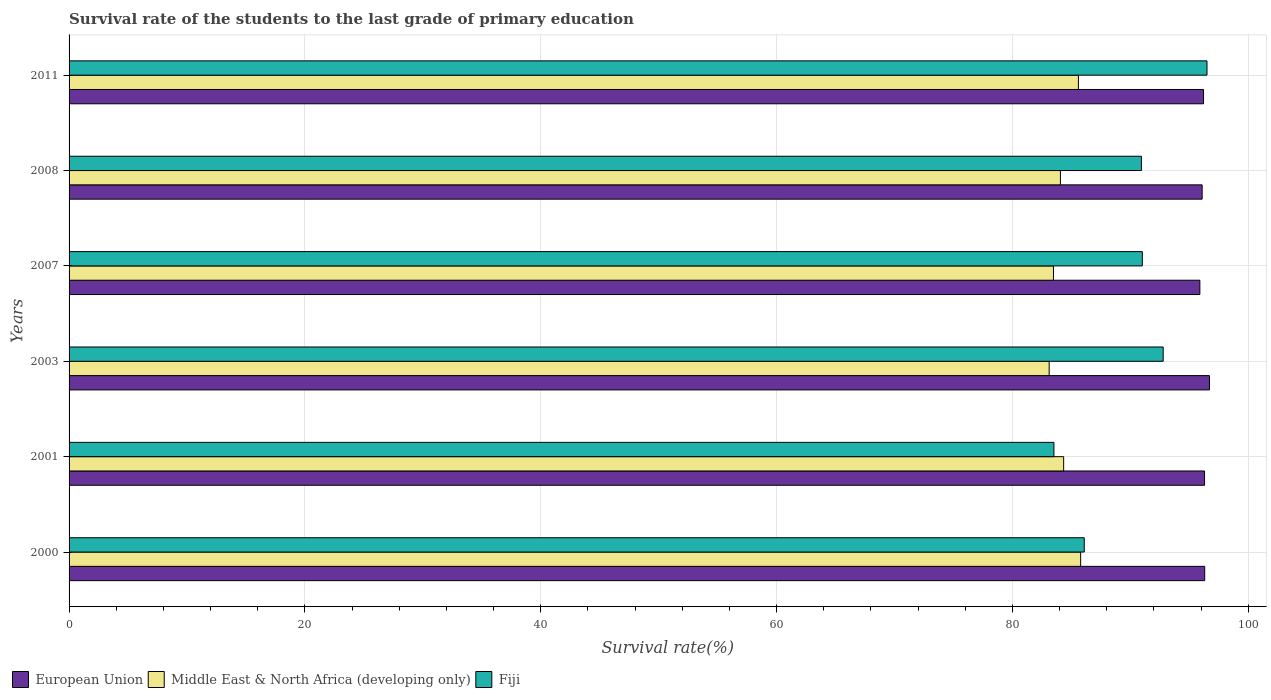How many different coloured bars are there?
Ensure brevity in your answer.  3. How many groups of bars are there?
Your response must be concise. 6. Are the number of bars on each tick of the Y-axis equal?
Provide a succinct answer. Yes. What is the survival rate of the students in Middle East & North Africa (developing only) in 2008?
Your response must be concise. 84.08. Across all years, what is the maximum survival rate of the students in Fiji?
Give a very brief answer. 96.51. Across all years, what is the minimum survival rate of the students in European Union?
Give a very brief answer. 95.9. In which year was the survival rate of the students in Middle East & North Africa (developing only) minimum?
Your response must be concise. 2003. What is the total survival rate of the students in Fiji in the graph?
Your answer should be compact. 540.89. What is the difference between the survival rate of the students in Middle East & North Africa (developing only) in 2008 and that in 2011?
Give a very brief answer. -1.53. What is the difference between the survival rate of the students in Middle East & North Africa (developing only) in 2011 and the survival rate of the students in European Union in 2008?
Make the answer very short. -10.49. What is the average survival rate of the students in European Union per year?
Offer a terse response. 96.26. In the year 2003, what is the difference between the survival rate of the students in European Union and survival rate of the students in Middle East & North Africa (developing only)?
Ensure brevity in your answer.  13.6. What is the ratio of the survival rate of the students in European Union in 2003 to that in 2011?
Provide a short and direct response. 1.01. Is the survival rate of the students in Middle East & North Africa (developing only) in 2000 less than that in 2007?
Provide a short and direct response. No. What is the difference between the highest and the second highest survival rate of the students in Middle East & North Africa (developing only)?
Provide a short and direct response. 0.19. What is the difference between the highest and the lowest survival rate of the students in Middle East & North Africa (developing only)?
Your answer should be compact. 2.67. Is the sum of the survival rate of the students in Middle East & North Africa (developing only) in 2000 and 2003 greater than the maximum survival rate of the students in European Union across all years?
Keep it short and to the point. Yes. What does the 2nd bar from the top in 2001 represents?
Your answer should be very brief. Middle East & North Africa (developing only). What does the 1st bar from the bottom in 2000 represents?
Offer a terse response. European Union. How many bars are there?
Ensure brevity in your answer.  18. Are all the bars in the graph horizontal?
Provide a succinct answer. Yes. What is the difference between two consecutive major ticks on the X-axis?
Your response must be concise. 20. Does the graph contain grids?
Your answer should be compact. Yes. Where does the legend appear in the graph?
Offer a very short reply. Bottom left. How many legend labels are there?
Make the answer very short. 3. What is the title of the graph?
Your answer should be compact. Survival rate of the students to the last grade of primary education. What is the label or title of the X-axis?
Make the answer very short. Survival rate(%). What is the label or title of the Y-axis?
Offer a terse response. Years. What is the Survival rate(%) in European Union in 2000?
Provide a short and direct response. 96.31. What is the Survival rate(%) in Middle East & North Africa (developing only) in 2000?
Provide a short and direct response. 85.79. What is the Survival rate(%) in Fiji in 2000?
Your answer should be very brief. 86.1. What is the Survival rate(%) of European Union in 2001?
Your answer should be very brief. 96.3. What is the Survival rate(%) of Middle East & North Africa (developing only) in 2001?
Ensure brevity in your answer.  84.35. What is the Survival rate(%) in Fiji in 2001?
Your response must be concise. 83.53. What is the Survival rate(%) of European Union in 2003?
Ensure brevity in your answer.  96.72. What is the Survival rate(%) of Middle East & North Africa (developing only) in 2003?
Keep it short and to the point. 83.12. What is the Survival rate(%) in Fiji in 2003?
Make the answer very short. 92.79. What is the Survival rate(%) in European Union in 2007?
Make the answer very short. 95.9. What is the Survival rate(%) in Middle East & North Africa (developing only) in 2007?
Your answer should be compact. 83.49. What is the Survival rate(%) in Fiji in 2007?
Provide a succinct answer. 91.02. What is the Survival rate(%) of European Union in 2008?
Your response must be concise. 96.1. What is the Survival rate(%) in Middle East & North Africa (developing only) in 2008?
Provide a succinct answer. 84.08. What is the Survival rate(%) of Fiji in 2008?
Give a very brief answer. 90.94. What is the Survival rate(%) in European Union in 2011?
Your response must be concise. 96.21. What is the Survival rate(%) in Middle East & North Africa (developing only) in 2011?
Offer a very short reply. 85.6. What is the Survival rate(%) in Fiji in 2011?
Your answer should be very brief. 96.51. Across all years, what is the maximum Survival rate(%) in European Union?
Your response must be concise. 96.72. Across all years, what is the maximum Survival rate(%) of Middle East & North Africa (developing only)?
Make the answer very short. 85.79. Across all years, what is the maximum Survival rate(%) of Fiji?
Provide a short and direct response. 96.51. Across all years, what is the minimum Survival rate(%) of European Union?
Your answer should be very brief. 95.9. Across all years, what is the minimum Survival rate(%) in Middle East & North Africa (developing only)?
Keep it short and to the point. 83.12. Across all years, what is the minimum Survival rate(%) in Fiji?
Make the answer very short. 83.53. What is the total Survival rate(%) in European Union in the graph?
Your answer should be compact. 577.54. What is the total Survival rate(%) of Middle East & North Africa (developing only) in the graph?
Offer a very short reply. 506.43. What is the total Survival rate(%) in Fiji in the graph?
Keep it short and to the point. 540.89. What is the difference between the Survival rate(%) of European Union in 2000 and that in 2001?
Provide a short and direct response. 0.01. What is the difference between the Survival rate(%) in Middle East & North Africa (developing only) in 2000 and that in 2001?
Offer a very short reply. 1.44. What is the difference between the Survival rate(%) in Fiji in 2000 and that in 2001?
Provide a short and direct response. 2.57. What is the difference between the Survival rate(%) of European Union in 2000 and that in 2003?
Give a very brief answer. -0.41. What is the difference between the Survival rate(%) in Middle East & North Africa (developing only) in 2000 and that in 2003?
Provide a short and direct response. 2.67. What is the difference between the Survival rate(%) in Fiji in 2000 and that in 2003?
Your response must be concise. -6.69. What is the difference between the Survival rate(%) of European Union in 2000 and that in 2007?
Your response must be concise. 0.41. What is the difference between the Survival rate(%) in Middle East & North Africa (developing only) in 2000 and that in 2007?
Give a very brief answer. 2.31. What is the difference between the Survival rate(%) of Fiji in 2000 and that in 2007?
Your response must be concise. -4.92. What is the difference between the Survival rate(%) of European Union in 2000 and that in 2008?
Your response must be concise. 0.22. What is the difference between the Survival rate(%) of Middle East & North Africa (developing only) in 2000 and that in 2008?
Provide a succinct answer. 1.72. What is the difference between the Survival rate(%) of Fiji in 2000 and that in 2008?
Your answer should be compact. -4.85. What is the difference between the Survival rate(%) in European Union in 2000 and that in 2011?
Ensure brevity in your answer.  0.1. What is the difference between the Survival rate(%) of Middle East & North Africa (developing only) in 2000 and that in 2011?
Make the answer very short. 0.19. What is the difference between the Survival rate(%) of Fiji in 2000 and that in 2011?
Ensure brevity in your answer.  -10.41. What is the difference between the Survival rate(%) in European Union in 2001 and that in 2003?
Keep it short and to the point. -0.42. What is the difference between the Survival rate(%) of Middle East & North Africa (developing only) in 2001 and that in 2003?
Offer a terse response. 1.23. What is the difference between the Survival rate(%) of Fiji in 2001 and that in 2003?
Make the answer very short. -9.27. What is the difference between the Survival rate(%) of European Union in 2001 and that in 2007?
Offer a terse response. 0.4. What is the difference between the Survival rate(%) in Middle East & North Africa (developing only) in 2001 and that in 2007?
Offer a terse response. 0.86. What is the difference between the Survival rate(%) of Fiji in 2001 and that in 2007?
Provide a succinct answer. -7.5. What is the difference between the Survival rate(%) of European Union in 2001 and that in 2008?
Provide a short and direct response. 0.2. What is the difference between the Survival rate(%) in Middle East & North Africa (developing only) in 2001 and that in 2008?
Keep it short and to the point. 0.27. What is the difference between the Survival rate(%) in Fiji in 2001 and that in 2008?
Give a very brief answer. -7.42. What is the difference between the Survival rate(%) in European Union in 2001 and that in 2011?
Provide a succinct answer. 0.08. What is the difference between the Survival rate(%) of Middle East & North Africa (developing only) in 2001 and that in 2011?
Your answer should be compact. -1.25. What is the difference between the Survival rate(%) of Fiji in 2001 and that in 2011?
Ensure brevity in your answer.  -12.98. What is the difference between the Survival rate(%) in European Union in 2003 and that in 2007?
Your answer should be very brief. 0.82. What is the difference between the Survival rate(%) of Middle East & North Africa (developing only) in 2003 and that in 2007?
Provide a succinct answer. -0.36. What is the difference between the Survival rate(%) of Fiji in 2003 and that in 2007?
Your response must be concise. 1.77. What is the difference between the Survival rate(%) of European Union in 2003 and that in 2008?
Your response must be concise. 0.62. What is the difference between the Survival rate(%) in Middle East & North Africa (developing only) in 2003 and that in 2008?
Offer a terse response. -0.95. What is the difference between the Survival rate(%) of Fiji in 2003 and that in 2008?
Provide a succinct answer. 1.85. What is the difference between the Survival rate(%) in European Union in 2003 and that in 2011?
Your answer should be compact. 0.5. What is the difference between the Survival rate(%) in Middle East & North Africa (developing only) in 2003 and that in 2011?
Offer a terse response. -2.48. What is the difference between the Survival rate(%) of Fiji in 2003 and that in 2011?
Your answer should be compact. -3.72. What is the difference between the Survival rate(%) of European Union in 2007 and that in 2008?
Make the answer very short. -0.19. What is the difference between the Survival rate(%) of Middle East & North Africa (developing only) in 2007 and that in 2008?
Keep it short and to the point. -0.59. What is the difference between the Survival rate(%) in Fiji in 2007 and that in 2008?
Your answer should be very brief. 0.08. What is the difference between the Survival rate(%) in European Union in 2007 and that in 2011?
Your answer should be very brief. -0.31. What is the difference between the Survival rate(%) in Middle East & North Africa (developing only) in 2007 and that in 2011?
Provide a short and direct response. -2.12. What is the difference between the Survival rate(%) in Fiji in 2007 and that in 2011?
Offer a very short reply. -5.49. What is the difference between the Survival rate(%) in European Union in 2008 and that in 2011?
Offer a very short reply. -0.12. What is the difference between the Survival rate(%) in Middle East & North Africa (developing only) in 2008 and that in 2011?
Offer a terse response. -1.53. What is the difference between the Survival rate(%) in Fiji in 2008 and that in 2011?
Ensure brevity in your answer.  -5.56. What is the difference between the Survival rate(%) in European Union in 2000 and the Survival rate(%) in Middle East & North Africa (developing only) in 2001?
Give a very brief answer. 11.96. What is the difference between the Survival rate(%) in European Union in 2000 and the Survival rate(%) in Fiji in 2001?
Offer a very short reply. 12.79. What is the difference between the Survival rate(%) in Middle East & North Africa (developing only) in 2000 and the Survival rate(%) in Fiji in 2001?
Keep it short and to the point. 2.27. What is the difference between the Survival rate(%) in European Union in 2000 and the Survival rate(%) in Middle East & North Africa (developing only) in 2003?
Give a very brief answer. 13.19. What is the difference between the Survival rate(%) of European Union in 2000 and the Survival rate(%) of Fiji in 2003?
Ensure brevity in your answer.  3.52. What is the difference between the Survival rate(%) in Middle East & North Africa (developing only) in 2000 and the Survival rate(%) in Fiji in 2003?
Give a very brief answer. -7. What is the difference between the Survival rate(%) in European Union in 2000 and the Survival rate(%) in Middle East & North Africa (developing only) in 2007?
Provide a short and direct response. 12.83. What is the difference between the Survival rate(%) in European Union in 2000 and the Survival rate(%) in Fiji in 2007?
Ensure brevity in your answer.  5.29. What is the difference between the Survival rate(%) of Middle East & North Africa (developing only) in 2000 and the Survival rate(%) of Fiji in 2007?
Make the answer very short. -5.23. What is the difference between the Survival rate(%) in European Union in 2000 and the Survival rate(%) in Middle East & North Africa (developing only) in 2008?
Your answer should be very brief. 12.24. What is the difference between the Survival rate(%) of European Union in 2000 and the Survival rate(%) of Fiji in 2008?
Keep it short and to the point. 5.37. What is the difference between the Survival rate(%) of Middle East & North Africa (developing only) in 2000 and the Survival rate(%) of Fiji in 2008?
Keep it short and to the point. -5.15. What is the difference between the Survival rate(%) of European Union in 2000 and the Survival rate(%) of Middle East & North Africa (developing only) in 2011?
Ensure brevity in your answer.  10.71. What is the difference between the Survival rate(%) in European Union in 2000 and the Survival rate(%) in Fiji in 2011?
Ensure brevity in your answer.  -0.2. What is the difference between the Survival rate(%) in Middle East & North Africa (developing only) in 2000 and the Survival rate(%) in Fiji in 2011?
Provide a succinct answer. -10.72. What is the difference between the Survival rate(%) in European Union in 2001 and the Survival rate(%) in Middle East & North Africa (developing only) in 2003?
Keep it short and to the point. 13.18. What is the difference between the Survival rate(%) in European Union in 2001 and the Survival rate(%) in Fiji in 2003?
Offer a terse response. 3.51. What is the difference between the Survival rate(%) of Middle East & North Africa (developing only) in 2001 and the Survival rate(%) of Fiji in 2003?
Your answer should be compact. -8.44. What is the difference between the Survival rate(%) of European Union in 2001 and the Survival rate(%) of Middle East & North Africa (developing only) in 2007?
Your answer should be compact. 12.81. What is the difference between the Survival rate(%) in European Union in 2001 and the Survival rate(%) in Fiji in 2007?
Make the answer very short. 5.28. What is the difference between the Survival rate(%) in Middle East & North Africa (developing only) in 2001 and the Survival rate(%) in Fiji in 2007?
Offer a terse response. -6.67. What is the difference between the Survival rate(%) of European Union in 2001 and the Survival rate(%) of Middle East & North Africa (developing only) in 2008?
Ensure brevity in your answer.  12.22. What is the difference between the Survival rate(%) of European Union in 2001 and the Survival rate(%) of Fiji in 2008?
Your answer should be compact. 5.35. What is the difference between the Survival rate(%) of Middle East & North Africa (developing only) in 2001 and the Survival rate(%) of Fiji in 2008?
Give a very brief answer. -6.59. What is the difference between the Survival rate(%) of European Union in 2001 and the Survival rate(%) of Middle East & North Africa (developing only) in 2011?
Your answer should be compact. 10.7. What is the difference between the Survival rate(%) in European Union in 2001 and the Survival rate(%) in Fiji in 2011?
Your answer should be compact. -0.21. What is the difference between the Survival rate(%) of Middle East & North Africa (developing only) in 2001 and the Survival rate(%) of Fiji in 2011?
Provide a succinct answer. -12.16. What is the difference between the Survival rate(%) in European Union in 2003 and the Survival rate(%) in Middle East & North Africa (developing only) in 2007?
Offer a terse response. 13.23. What is the difference between the Survival rate(%) of European Union in 2003 and the Survival rate(%) of Fiji in 2007?
Offer a very short reply. 5.7. What is the difference between the Survival rate(%) in Middle East & North Africa (developing only) in 2003 and the Survival rate(%) in Fiji in 2007?
Give a very brief answer. -7.9. What is the difference between the Survival rate(%) in European Union in 2003 and the Survival rate(%) in Middle East & North Africa (developing only) in 2008?
Ensure brevity in your answer.  12.64. What is the difference between the Survival rate(%) of European Union in 2003 and the Survival rate(%) of Fiji in 2008?
Your answer should be compact. 5.77. What is the difference between the Survival rate(%) in Middle East & North Africa (developing only) in 2003 and the Survival rate(%) in Fiji in 2008?
Make the answer very short. -7.82. What is the difference between the Survival rate(%) in European Union in 2003 and the Survival rate(%) in Middle East & North Africa (developing only) in 2011?
Give a very brief answer. 11.12. What is the difference between the Survival rate(%) of European Union in 2003 and the Survival rate(%) of Fiji in 2011?
Keep it short and to the point. 0.21. What is the difference between the Survival rate(%) of Middle East & North Africa (developing only) in 2003 and the Survival rate(%) of Fiji in 2011?
Provide a short and direct response. -13.39. What is the difference between the Survival rate(%) in European Union in 2007 and the Survival rate(%) in Middle East & North Africa (developing only) in 2008?
Give a very brief answer. 11.83. What is the difference between the Survival rate(%) of European Union in 2007 and the Survival rate(%) of Fiji in 2008?
Ensure brevity in your answer.  4.96. What is the difference between the Survival rate(%) in Middle East & North Africa (developing only) in 2007 and the Survival rate(%) in Fiji in 2008?
Provide a succinct answer. -7.46. What is the difference between the Survival rate(%) in European Union in 2007 and the Survival rate(%) in Middle East & North Africa (developing only) in 2011?
Your answer should be compact. 10.3. What is the difference between the Survival rate(%) in European Union in 2007 and the Survival rate(%) in Fiji in 2011?
Keep it short and to the point. -0.61. What is the difference between the Survival rate(%) of Middle East & North Africa (developing only) in 2007 and the Survival rate(%) of Fiji in 2011?
Offer a very short reply. -13.02. What is the difference between the Survival rate(%) of European Union in 2008 and the Survival rate(%) of Middle East & North Africa (developing only) in 2011?
Provide a succinct answer. 10.49. What is the difference between the Survival rate(%) of European Union in 2008 and the Survival rate(%) of Fiji in 2011?
Your answer should be compact. -0.41. What is the difference between the Survival rate(%) in Middle East & North Africa (developing only) in 2008 and the Survival rate(%) in Fiji in 2011?
Provide a succinct answer. -12.43. What is the average Survival rate(%) of European Union per year?
Provide a succinct answer. 96.26. What is the average Survival rate(%) in Middle East & North Africa (developing only) per year?
Offer a terse response. 84.41. What is the average Survival rate(%) of Fiji per year?
Your response must be concise. 90.15. In the year 2000, what is the difference between the Survival rate(%) of European Union and Survival rate(%) of Middle East & North Africa (developing only)?
Provide a short and direct response. 10.52. In the year 2000, what is the difference between the Survival rate(%) of European Union and Survival rate(%) of Fiji?
Offer a very short reply. 10.21. In the year 2000, what is the difference between the Survival rate(%) of Middle East & North Africa (developing only) and Survival rate(%) of Fiji?
Your response must be concise. -0.31. In the year 2001, what is the difference between the Survival rate(%) in European Union and Survival rate(%) in Middle East & North Africa (developing only)?
Your response must be concise. 11.95. In the year 2001, what is the difference between the Survival rate(%) in European Union and Survival rate(%) in Fiji?
Give a very brief answer. 12.77. In the year 2001, what is the difference between the Survival rate(%) of Middle East & North Africa (developing only) and Survival rate(%) of Fiji?
Your response must be concise. 0.82. In the year 2003, what is the difference between the Survival rate(%) in European Union and Survival rate(%) in Middle East & North Africa (developing only)?
Provide a short and direct response. 13.6. In the year 2003, what is the difference between the Survival rate(%) of European Union and Survival rate(%) of Fiji?
Provide a succinct answer. 3.93. In the year 2003, what is the difference between the Survival rate(%) of Middle East & North Africa (developing only) and Survival rate(%) of Fiji?
Your answer should be very brief. -9.67. In the year 2007, what is the difference between the Survival rate(%) of European Union and Survival rate(%) of Middle East & North Africa (developing only)?
Provide a short and direct response. 12.41. In the year 2007, what is the difference between the Survival rate(%) of European Union and Survival rate(%) of Fiji?
Ensure brevity in your answer.  4.88. In the year 2007, what is the difference between the Survival rate(%) in Middle East & North Africa (developing only) and Survival rate(%) in Fiji?
Keep it short and to the point. -7.54. In the year 2008, what is the difference between the Survival rate(%) of European Union and Survival rate(%) of Middle East & North Africa (developing only)?
Offer a terse response. 12.02. In the year 2008, what is the difference between the Survival rate(%) of European Union and Survival rate(%) of Fiji?
Your answer should be very brief. 5.15. In the year 2008, what is the difference between the Survival rate(%) of Middle East & North Africa (developing only) and Survival rate(%) of Fiji?
Your answer should be very brief. -6.87. In the year 2011, what is the difference between the Survival rate(%) of European Union and Survival rate(%) of Middle East & North Africa (developing only)?
Your answer should be very brief. 10.61. In the year 2011, what is the difference between the Survival rate(%) in European Union and Survival rate(%) in Fiji?
Give a very brief answer. -0.29. In the year 2011, what is the difference between the Survival rate(%) in Middle East & North Africa (developing only) and Survival rate(%) in Fiji?
Make the answer very short. -10.91. What is the ratio of the Survival rate(%) of European Union in 2000 to that in 2001?
Your answer should be compact. 1. What is the ratio of the Survival rate(%) of Middle East & North Africa (developing only) in 2000 to that in 2001?
Ensure brevity in your answer.  1.02. What is the ratio of the Survival rate(%) in Fiji in 2000 to that in 2001?
Ensure brevity in your answer.  1.03. What is the ratio of the Survival rate(%) of Middle East & North Africa (developing only) in 2000 to that in 2003?
Provide a succinct answer. 1.03. What is the ratio of the Survival rate(%) of Fiji in 2000 to that in 2003?
Your answer should be compact. 0.93. What is the ratio of the Survival rate(%) in Middle East & North Africa (developing only) in 2000 to that in 2007?
Keep it short and to the point. 1.03. What is the ratio of the Survival rate(%) in Fiji in 2000 to that in 2007?
Provide a short and direct response. 0.95. What is the ratio of the Survival rate(%) in European Union in 2000 to that in 2008?
Offer a very short reply. 1. What is the ratio of the Survival rate(%) in Middle East & North Africa (developing only) in 2000 to that in 2008?
Make the answer very short. 1.02. What is the ratio of the Survival rate(%) of Fiji in 2000 to that in 2008?
Ensure brevity in your answer.  0.95. What is the ratio of the Survival rate(%) in European Union in 2000 to that in 2011?
Give a very brief answer. 1. What is the ratio of the Survival rate(%) of Middle East & North Africa (developing only) in 2000 to that in 2011?
Keep it short and to the point. 1. What is the ratio of the Survival rate(%) of Fiji in 2000 to that in 2011?
Offer a terse response. 0.89. What is the ratio of the Survival rate(%) of European Union in 2001 to that in 2003?
Offer a very short reply. 1. What is the ratio of the Survival rate(%) of Middle East & North Africa (developing only) in 2001 to that in 2003?
Your response must be concise. 1.01. What is the ratio of the Survival rate(%) of Fiji in 2001 to that in 2003?
Offer a very short reply. 0.9. What is the ratio of the Survival rate(%) of European Union in 2001 to that in 2007?
Offer a terse response. 1. What is the ratio of the Survival rate(%) in Middle East & North Africa (developing only) in 2001 to that in 2007?
Your response must be concise. 1.01. What is the ratio of the Survival rate(%) of Fiji in 2001 to that in 2007?
Make the answer very short. 0.92. What is the ratio of the Survival rate(%) in Fiji in 2001 to that in 2008?
Your response must be concise. 0.92. What is the ratio of the Survival rate(%) of Middle East & North Africa (developing only) in 2001 to that in 2011?
Provide a succinct answer. 0.99. What is the ratio of the Survival rate(%) of Fiji in 2001 to that in 2011?
Your response must be concise. 0.87. What is the ratio of the Survival rate(%) of European Union in 2003 to that in 2007?
Your answer should be very brief. 1.01. What is the ratio of the Survival rate(%) in Middle East & North Africa (developing only) in 2003 to that in 2007?
Your answer should be compact. 1. What is the ratio of the Survival rate(%) in Fiji in 2003 to that in 2007?
Provide a succinct answer. 1.02. What is the ratio of the Survival rate(%) in European Union in 2003 to that in 2008?
Provide a succinct answer. 1.01. What is the ratio of the Survival rate(%) of Middle East & North Africa (developing only) in 2003 to that in 2008?
Offer a very short reply. 0.99. What is the ratio of the Survival rate(%) in Fiji in 2003 to that in 2008?
Make the answer very short. 1.02. What is the ratio of the Survival rate(%) in Middle East & North Africa (developing only) in 2003 to that in 2011?
Provide a short and direct response. 0.97. What is the ratio of the Survival rate(%) of Fiji in 2003 to that in 2011?
Offer a very short reply. 0.96. What is the ratio of the Survival rate(%) in European Union in 2007 to that in 2008?
Give a very brief answer. 1. What is the ratio of the Survival rate(%) in Middle East & North Africa (developing only) in 2007 to that in 2008?
Offer a very short reply. 0.99. What is the ratio of the Survival rate(%) of Fiji in 2007 to that in 2008?
Ensure brevity in your answer.  1. What is the ratio of the Survival rate(%) of European Union in 2007 to that in 2011?
Offer a terse response. 1. What is the ratio of the Survival rate(%) in Middle East & North Africa (developing only) in 2007 to that in 2011?
Ensure brevity in your answer.  0.98. What is the ratio of the Survival rate(%) of Fiji in 2007 to that in 2011?
Offer a very short reply. 0.94. What is the ratio of the Survival rate(%) of Middle East & North Africa (developing only) in 2008 to that in 2011?
Your answer should be very brief. 0.98. What is the ratio of the Survival rate(%) in Fiji in 2008 to that in 2011?
Offer a terse response. 0.94. What is the difference between the highest and the second highest Survival rate(%) of European Union?
Your answer should be compact. 0.41. What is the difference between the highest and the second highest Survival rate(%) of Middle East & North Africa (developing only)?
Offer a very short reply. 0.19. What is the difference between the highest and the second highest Survival rate(%) in Fiji?
Your answer should be compact. 3.72. What is the difference between the highest and the lowest Survival rate(%) of European Union?
Give a very brief answer. 0.82. What is the difference between the highest and the lowest Survival rate(%) in Middle East & North Africa (developing only)?
Provide a short and direct response. 2.67. What is the difference between the highest and the lowest Survival rate(%) in Fiji?
Give a very brief answer. 12.98. 